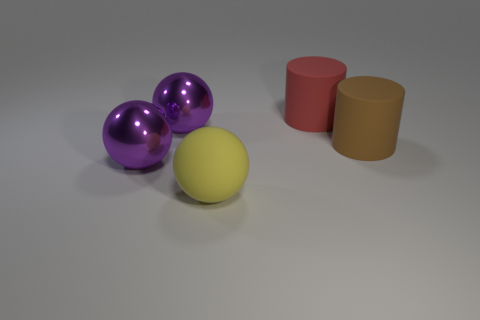Subtract all shiny spheres. How many spheres are left? 1 Add 5 tiny brown cubes. How many objects exist? 10 Subtract all yellow spheres. How many spheres are left? 2 Subtract all red blocks. How many purple balls are left? 2 Subtract all spheres. How many objects are left? 2 Subtract 1 cylinders. How many cylinders are left? 1 Subtract all big purple metallic spheres. Subtract all big cylinders. How many objects are left? 1 Add 3 big brown rubber cylinders. How many big brown rubber cylinders are left? 4 Add 1 big cyan balls. How many big cyan balls exist? 1 Subtract 0 purple cylinders. How many objects are left? 5 